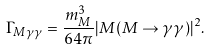Convert formula to latex. <formula><loc_0><loc_0><loc_500><loc_500>\Gamma _ { M \gamma \gamma } = \frac { m ^ { 3 } _ { M } } { 6 4 \pi } | M ( M \to \gamma \gamma ) | ^ { 2 } .</formula> 